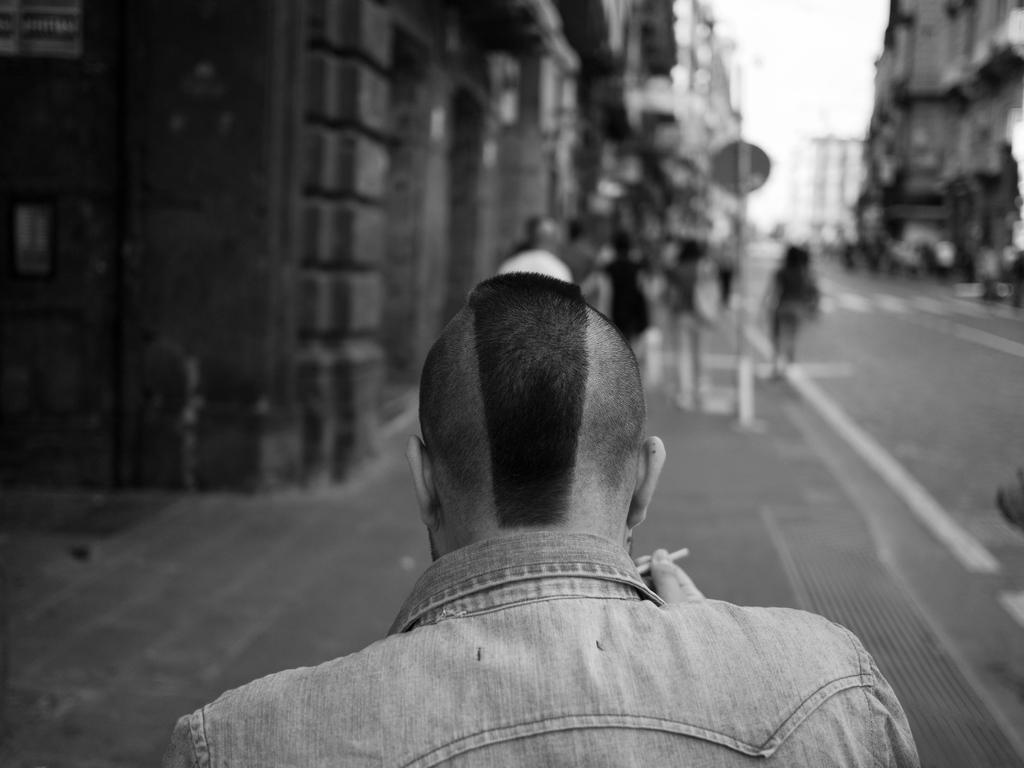In one or two sentences, can you explain what this image depicts? In this picture we can see a few people on the path. We can see buildings, other objects and the sky. Background is blurry. 